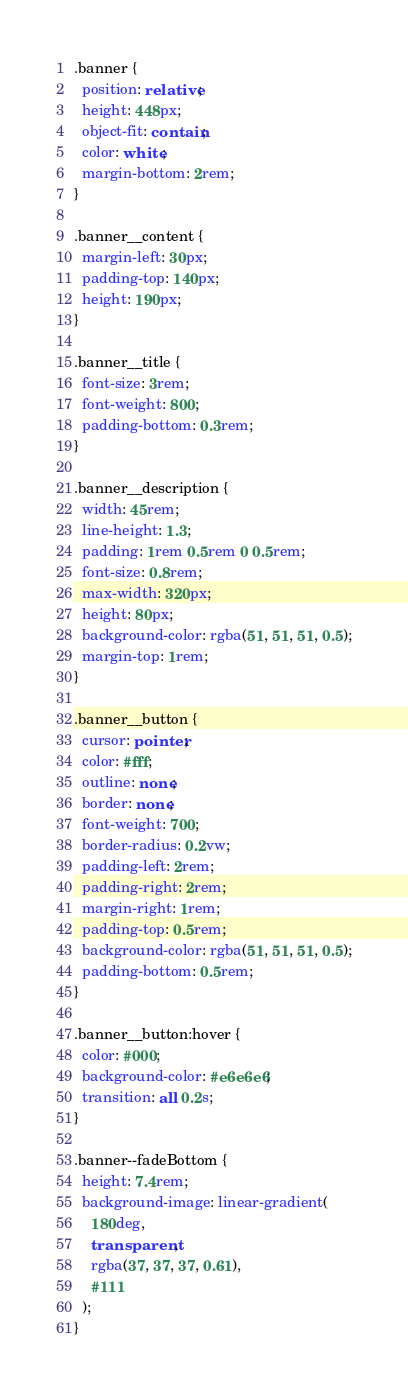Convert code to text. <code><loc_0><loc_0><loc_500><loc_500><_CSS_>.banner {
  position: relative;
  height: 448px;
  object-fit: contain;
  color: white;
  margin-bottom: 2rem;
}

.banner__content {
  margin-left: 30px;
  padding-top: 140px;
  height: 190px;
}

.banner__title {
  font-size: 3rem;
  font-weight: 800;
  padding-bottom: 0.3rem;
}

.banner__description {
  width: 45rem;
  line-height: 1.3;
  padding: 1rem 0.5rem 0 0.5rem;
  font-size: 0.8rem;
  max-width: 320px;
  height: 80px;
  background-color: rgba(51, 51, 51, 0.5);
  margin-top: 1rem;
}

.banner__button {
  cursor: pointer;
  color: #fff;
  outline: none;
  border: none;
  font-weight: 700;
  border-radius: 0.2vw;
  padding-left: 2rem;
  padding-right: 2rem;
  margin-right: 1rem;
  padding-top: 0.5rem;
  background-color: rgba(51, 51, 51, 0.5);
  padding-bottom: 0.5rem;
}

.banner__button:hover {
  color: #000;
  background-color: #e6e6e6;
  transition: all 0.2s;
}

.banner--fadeBottom {
  height: 7.4rem;
  background-image: linear-gradient(
    180deg,
    transparent,
    rgba(37, 37, 37, 0.61),
    #111
  );
}
</code> 